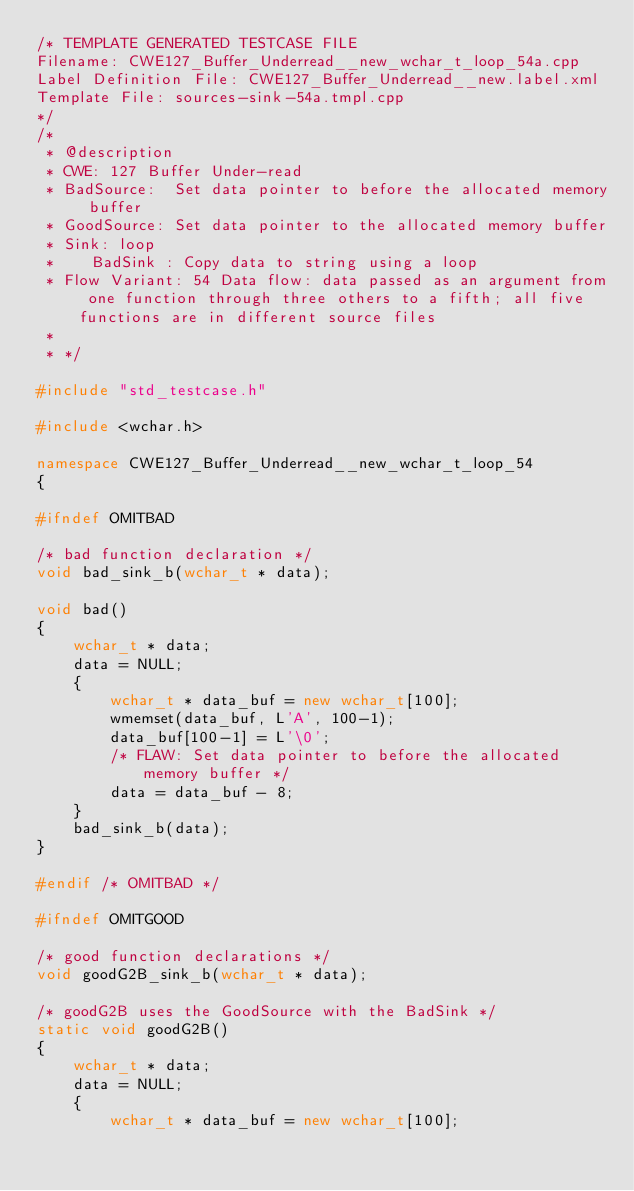Convert code to text. <code><loc_0><loc_0><loc_500><loc_500><_C++_>/* TEMPLATE GENERATED TESTCASE FILE
Filename: CWE127_Buffer_Underread__new_wchar_t_loop_54a.cpp
Label Definition File: CWE127_Buffer_Underread__new.label.xml
Template File: sources-sink-54a.tmpl.cpp
*/
/*
 * @description
 * CWE: 127 Buffer Under-read
 * BadSource:  Set data pointer to before the allocated memory buffer
 * GoodSource: Set data pointer to the allocated memory buffer
 * Sink: loop
 *    BadSink : Copy data to string using a loop
 * Flow Variant: 54 Data flow: data passed as an argument from one function through three others to a fifth; all five functions are in different source files
 *
 * */

#include "std_testcase.h"

#include <wchar.h>

namespace CWE127_Buffer_Underread__new_wchar_t_loop_54
{

#ifndef OMITBAD

/* bad function declaration */
void bad_sink_b(wchar_t * data);

void bad()
{
    wchar_t * data;
    data = NULL;
    {
        wchar_t * data_buf = new wchar_t[100];
        wmemset(data_buf, L'A', 100-1);
        data_buf[100-1] = L'\0';
        /* FLAW: Set data pointer to before the allocated memory buffer */
        data = data_buf - 8;
    }
    bad_sink_b(data);
}

#endif /* OMITBAD */

#ifndef OMITGOOD

/* good function declarations */
void goodG2B_sink_b(wchar_t * data);

/* goodG2B uses the GoodSource with the BadSink */
static void goodG2B()
{
    wchar_t * data;
    data = NULL;
    {
        wchar_t * data_buf = new wchar_t[100];</code> 